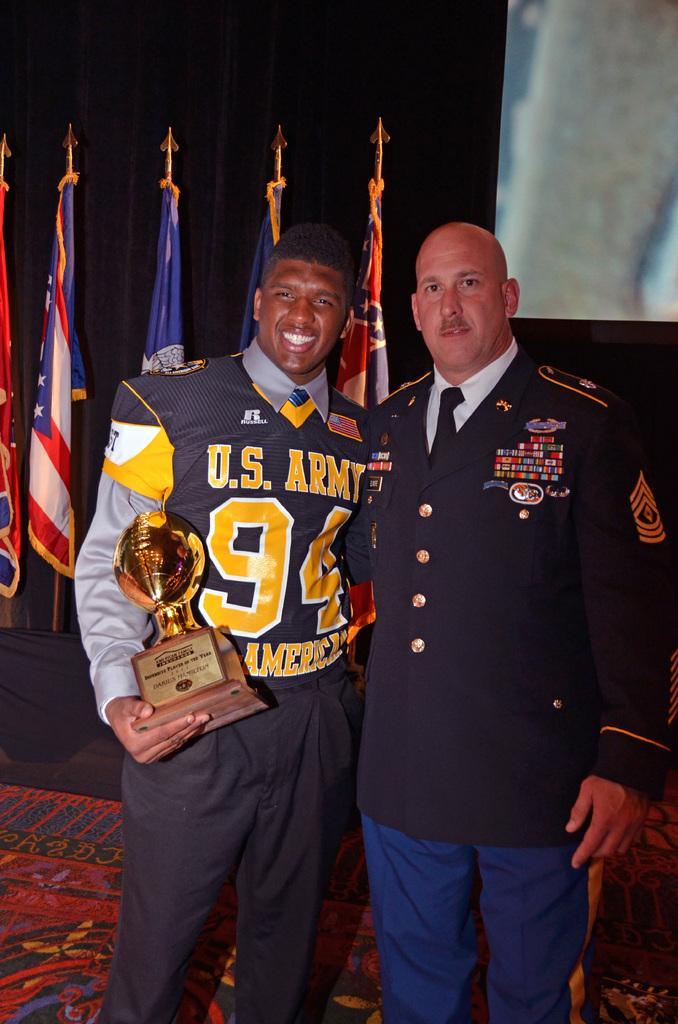What branch of the military is on the mans shirts?
Keep it short and to the point. Army. What number is on the jersey?
Ensure brevity in your answer.  94. 